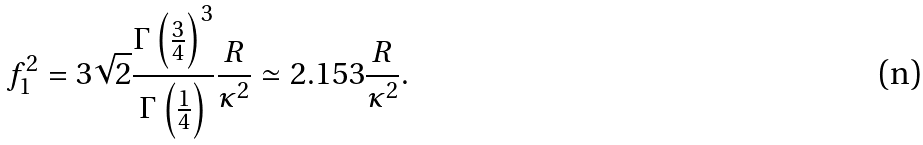<formula> <loc_0><loc_0><loc_500><loc_500>f _ { 1 } ^ { 2 } & = 3 \sqrt { 2 } \frac { \Gamma \left ( \frac { 3 } { 4 } \right ) ^ { 3 } } { \Gamma \left ( \frac { 1 } { 4 } \right ) } \frac { R } { \kappa ^ { 2 } } \simeq 2 . 1 5 3 \frac { R } { \kappa ^ { 2 } } .</formula> 